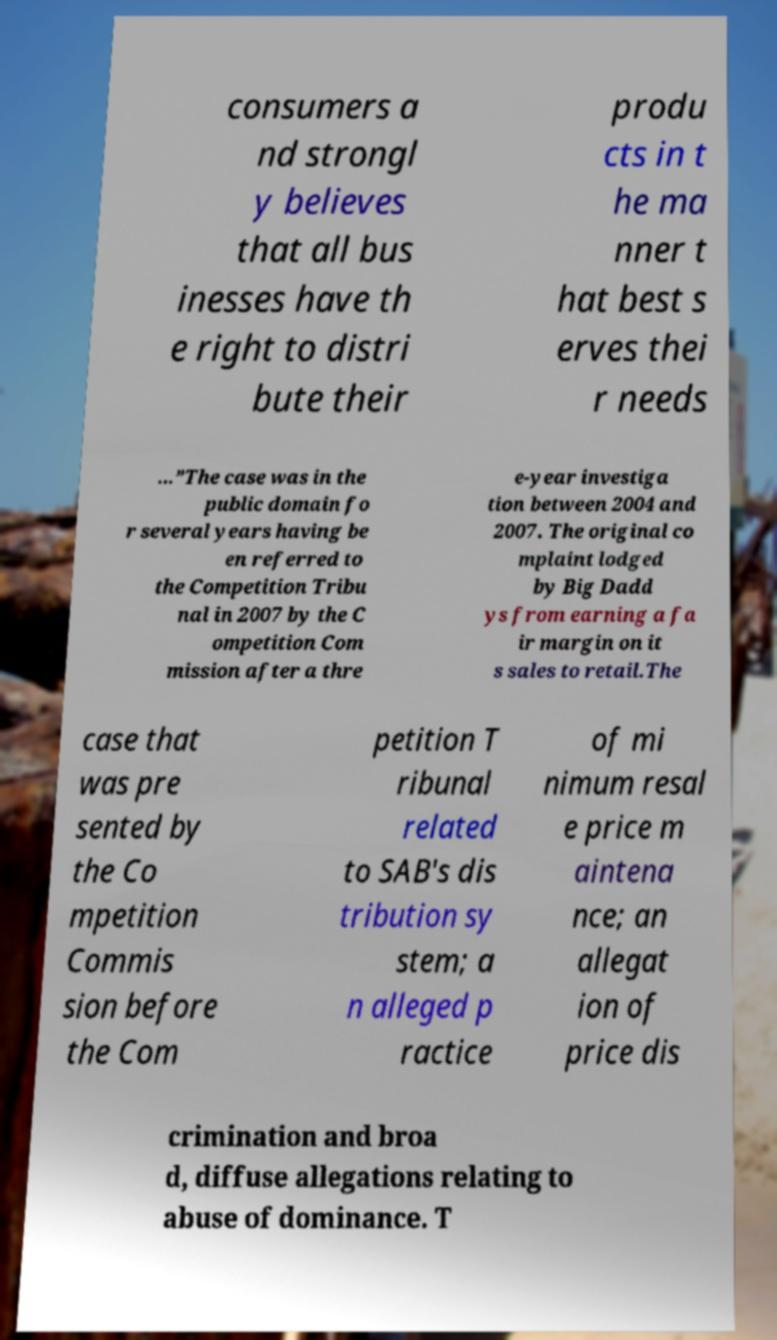Could you assist in decoding the text presented in this image and type it out clearly? consumers a nd strongl y believes that all bus inesses have th e right to distri bute their produ cts in t he ma nner t hat best s erves thei r needs …”The case was in the public domain fo r several years having be en referred to the Competition Tribu nal in 2007 by the C ompetition Com mission after a thre e-year investiga tion between 2004 and 2007. The original co mplaint lodged by Big Dadd ys from earning a fa ir margin on it s sales to retail.The case that was pre sented by the Co mpetition Commis sion before the Com petition T ribunal related to SAB's dis tribution sy stem; a n alleged p ractice of mi nimum resal e price m aintena nce; an allegat ion of price dis crimination and broa d, diffuse allegations relating to abuse of dominance. T 